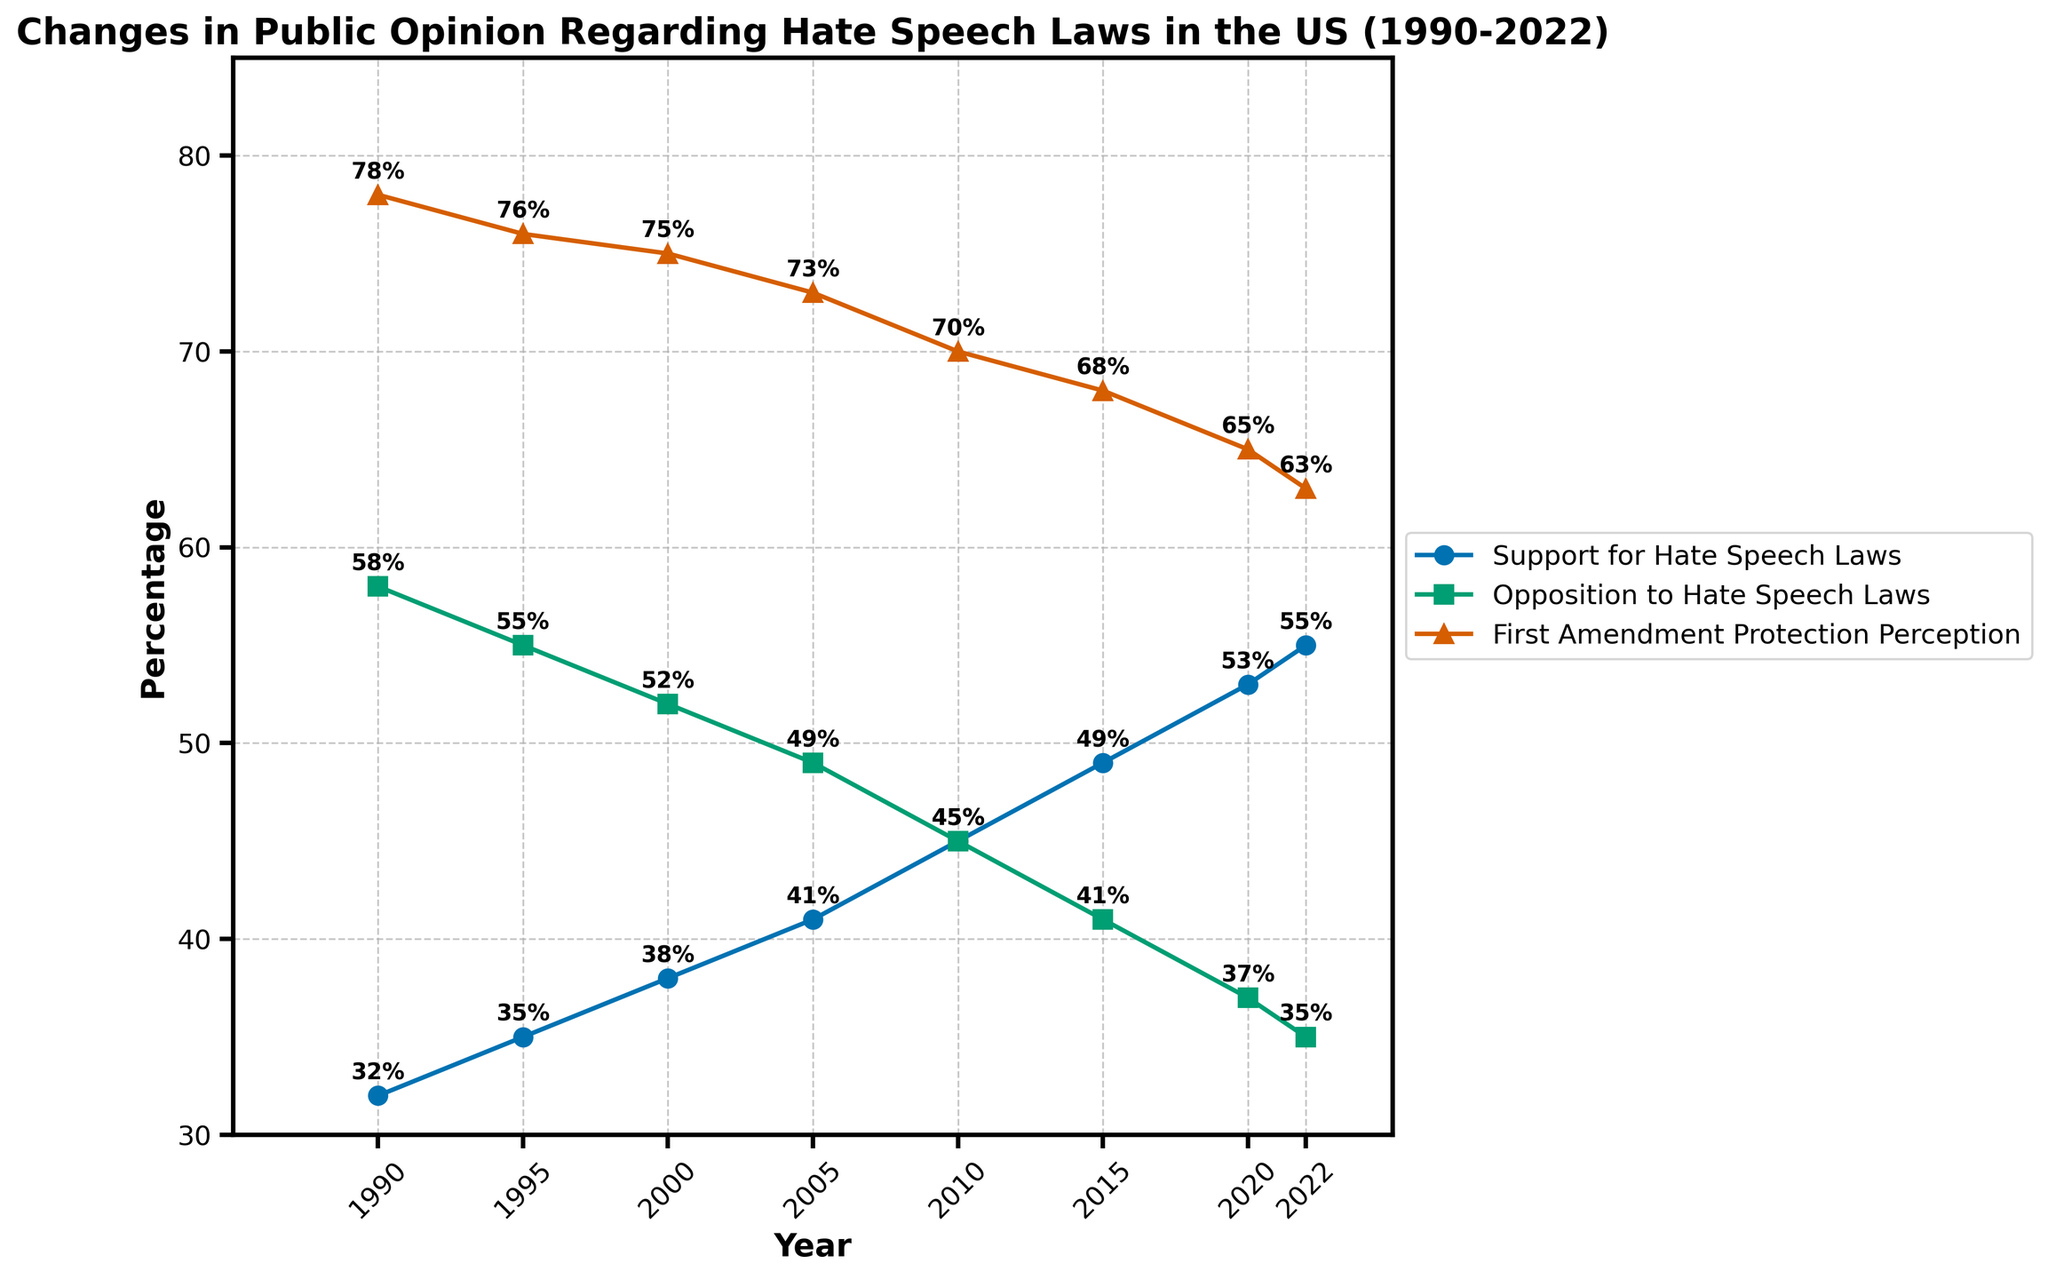What is the trend in public support for hate speech laws from 1990 to 2022? The data shows a gradual increase in public support for hate speech laws over the years. Starting from 32% in 1990 and reaching 55% in 2022.
Answer: Increasing How does the level of opposition to hate speech laws in 2022 compare to 1990? In 1990, opposition was at 58%, whereas, in 2022, it fell to 35%. This shows a significant decrease of 23 percentage points.
Answer: Decreased by 23 percentage points What can be observed about the percentage of people who perceive hate speech laws as First Amendment protection between 1990 and 2022? The perception of hate speech laws as First Amendment protection has gradually declined from 78% in 1990 to 63% in 2022.
Answer: Decreasing Which year marked the first instance when support for hate speech laws equaled opposition to those laws? In 2010, both support and opposition to hate speech laws were at 45%, marking the year they were equal.
Answer: 2010 If one were to compute the average support for hate speech laws between 1990 and 2022, what would it be? Add the support percentages from each year and divide by the number of data points: (32+35+38+41+45+49+53+55)/8 = 43.5%
Answer: 43.5% Compare the trends of support for hate speech laws and perception of First Amendment protection between 1990 to 2022. Support for hate speech laws increases while perception of First Amendment protection decreases over the same period.
Answer: Opposite trends Between which consecutive years did the highest increase in support for hate speech laws occur? Compare the differences: 1990-1995: 3%, 1995-2000: 3%, 2000-2005: 3%, 2005-2010: 4%, 2010-2015: 4%, 2015-2020: 4%, 2020-2022: 2%. The highest increase was between 2010 to 2015 and 2015 to 2020 with 4%.
Answer: 2010 to 2015 and 2015 to 2020 Based on the plotted data, how did the trend for opposition to hate speech laws change from 2005 to 2015? The trend shows a steady decline in opposition from 49% in 2005 to 41% in 2015, indicating a drop of 8 percentage points over this period.
Answer: Decreasing What is the difference between the highest and lowest perceptions of First Amendment protection from 1990 to 2022? The highest perception was 78% in 1990, and the lowest was 63% in 2022. The difference is 78% - 63% = 15%.
Answer: 15% How did the percentage of people supporting hate speech laws change from 1990 to 2000, and how does it compare to the change from 2000 to 2022? From 1990 to 2000, support increased by 6% (32% to 38%). From 2000 to 2022, it increased by 17% (38% to 55%). Thus, the growth was faster from 2000 to 2022.
Answer: Faster growth from 2000 to 2022 